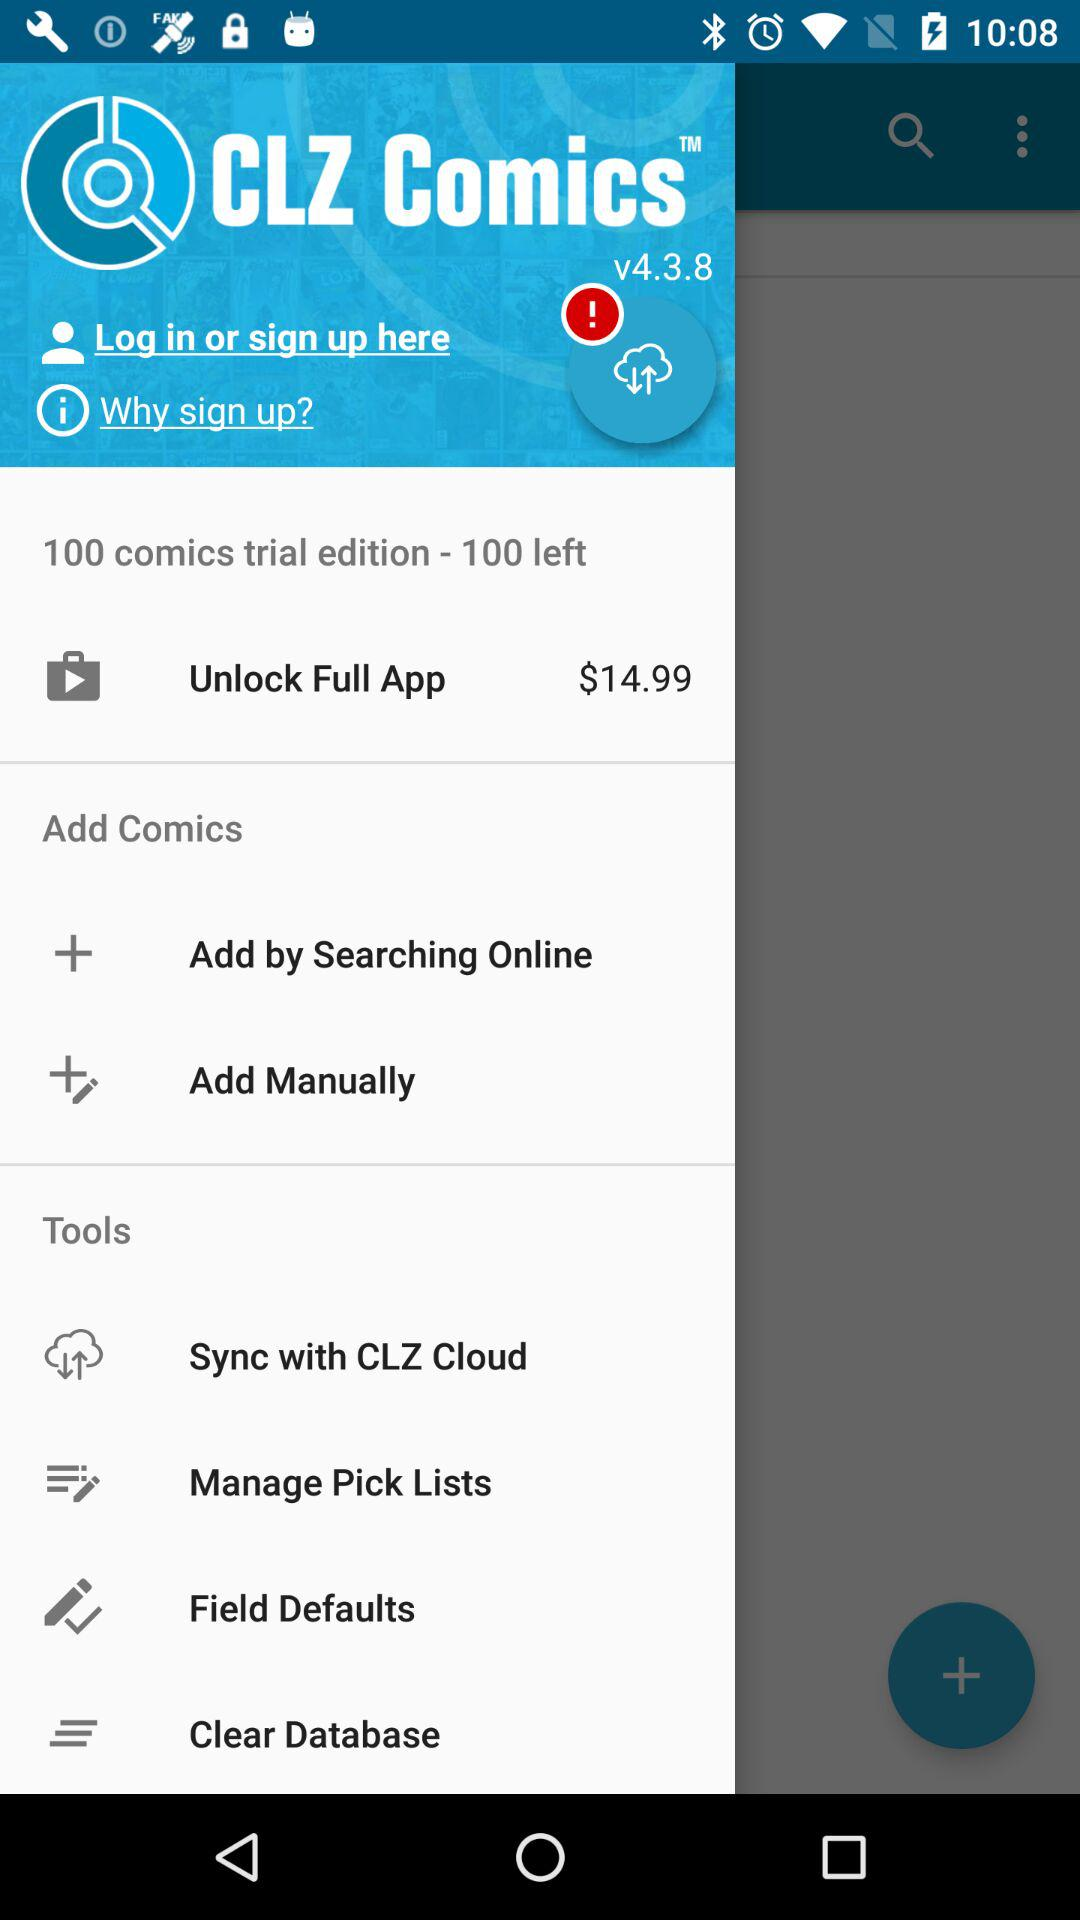What is the name of the application? The name of the application is "CLZ Comics". 